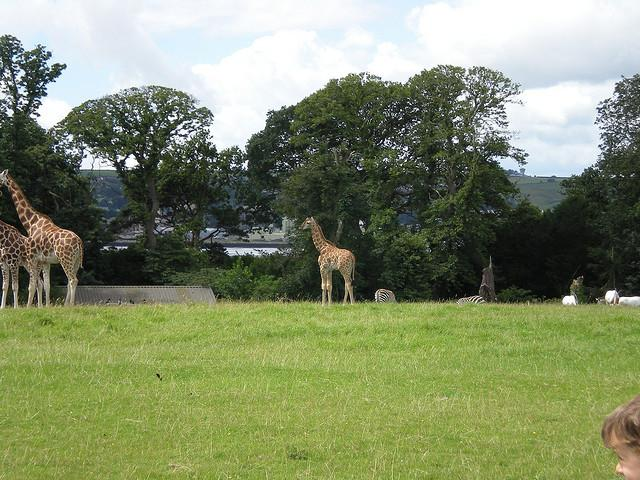What are the zebras doing? Please explain your reasoning. feeding. The zebras are visible with their heads down. when zebras move across a grassy surface with their heads down it is most likely for the purpose of eating. 